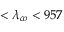Convert formula to latex. <formula><loc_0><loc_0><loc_500><loc_500>< \lambda _ { c o } < 9 5 7</formula> 